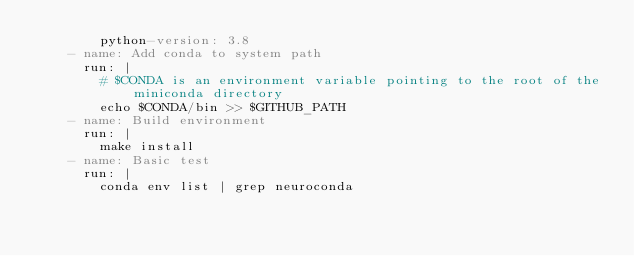<code> <loc_0><loc_0><loc_500><loc_500><_YAML_>        python-version: 3.8
    - name: Add conda to system path
      run: |
        # $CONDA is an environment variable pointing to the root of the miniconda directory
        echo $CONDA/bin >> $GITHUB_PATH
    - name: Build environment
      run: |
        make install
    - name: Basic test
      run: |
        conda env list | grep neuroconda
</code> 